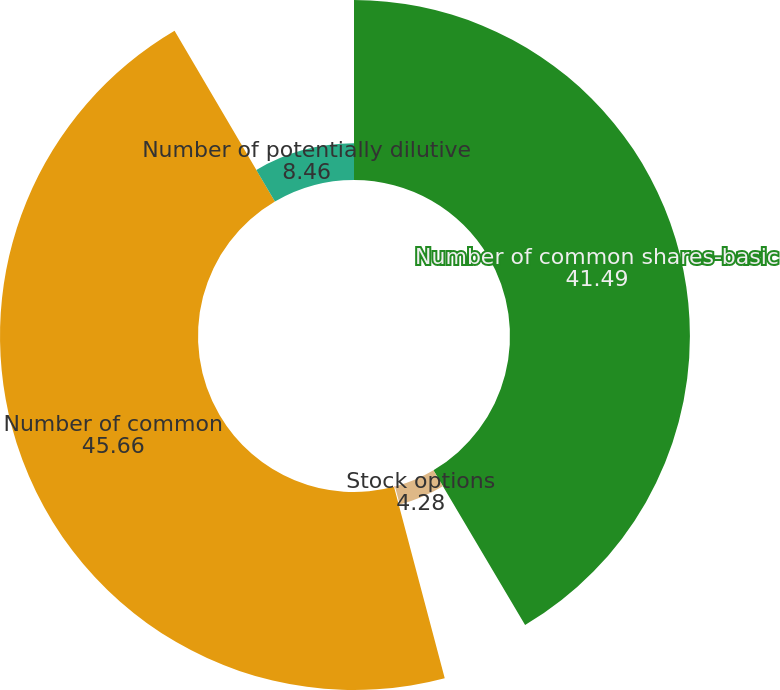Convert chart to OTSL. <chart><loc_0><loc_0><loc_500><loc_500><pie_chart><fcel>Number of common shares-basic<fcel>Stock options<fcel>Restricted stock awards<fcel>Number of common<fcel>Number of potentially dilutive<nl><fcel>41.49%<fcel>4.28%<fcel>0.1%<fcel>45.66%<fcel>8.46%<nl></chart> 